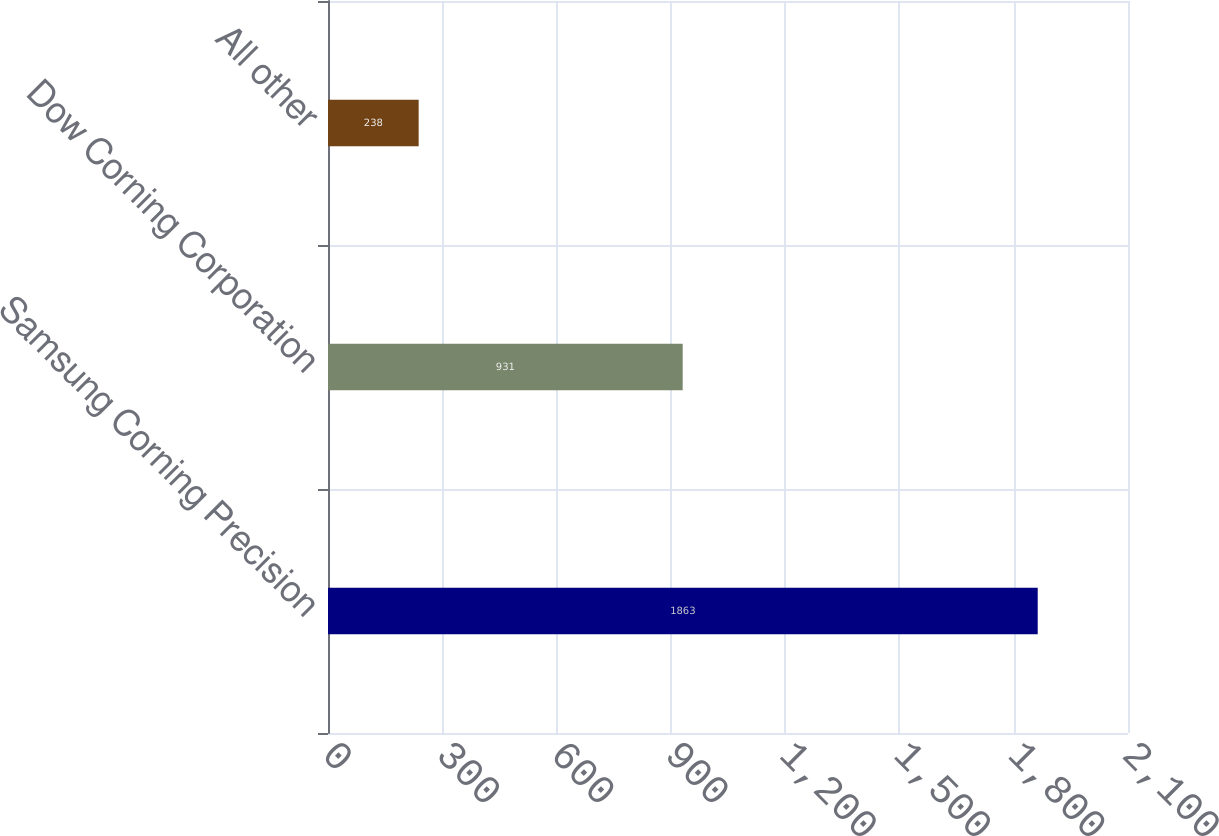Convert chart. <chart><loc_0><loc_0><loc_500><loc_500><bar_chart><fcel>Samsung Corning Precision<fcel>Dow Corning Corporation<fcel>All other<nl><fcel>1863<fcel>931<fcel>238<nl></chart> 